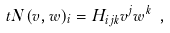<formula> <loc_0><loc_0><loc_500><loc_500>\ t N ( v , w ) _ { i } = H _ { i j k } v ^ { j } w ^ { k } \ ,</formula> 